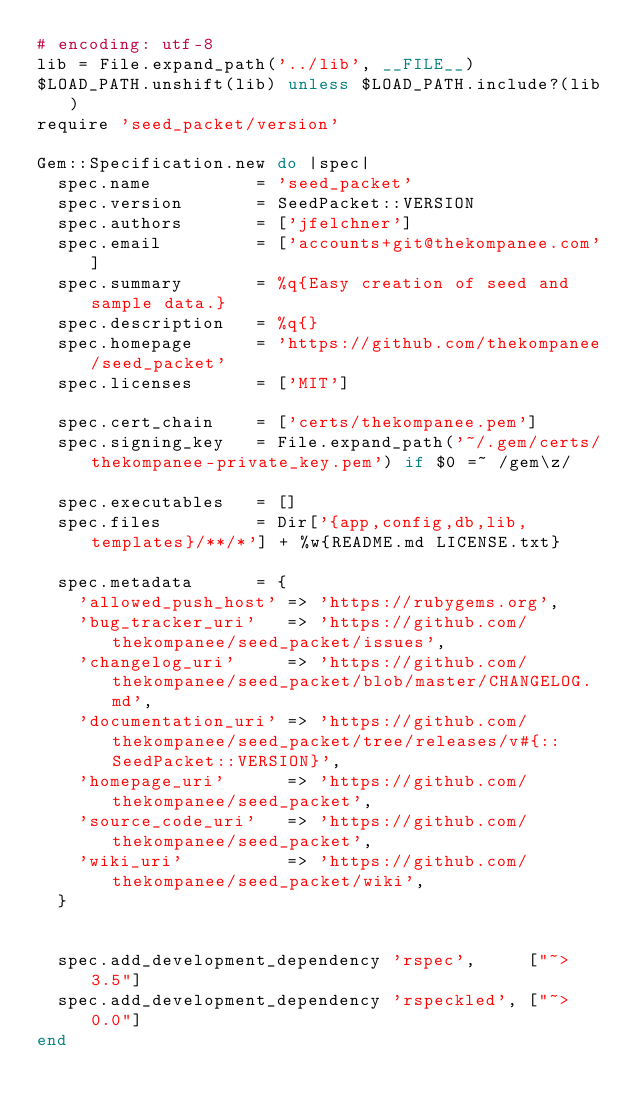Convert code to text. <code><loc_0><loc_0><loc_500><loc_500><_Ruby_># encoding: utf-8
lib = File.expand_path('../lib', __FILE__)
$LOAD_PATH.unshift(lib) unless $LOAD_PATH.include?(lib)
require 'seed_packet/version'

Gem::Specification.new do |spec|
  spec.name          = 'seed_packet'
  spec.version       = SeedPacket::VERSION
  spec.authors       = ['jfelchner']
  spec.email         = ['accounts+git@thekompanee.com']
  spec.summary       = %q{Easy creation of seed and sample data.}
  spec.description   = %q{}
  spec.homepage      = 'https://github.com/thekompanee/seed_packet'
  spec.licenses      = ['MIT']

  spec.cert_chain    = ['certs/thekompanee.pem']
  spec.signing_key   = File.expand_path('~/.gem/certs/thekompanee-private_key.pem') if $0 =~ /gem\z/

  spec.executables   = []
  spec.files         = Dir['{app,config,db,lib,templates}/**/*'] + %w{README.md LICENSE.txt}

  spec.metadata      = {
    'allowed_push_host' => 'https://rubygems.org',
    'bug_tracker_uri'   => 'https://github.com/thekompanee/seed_packet/issues',
    'changelog_uri'     => 'https://github.com/thekompanee/seed_packet/blob/master/CHANGELOG.md',
    'documentation_uri' => 'https://github.com/thekompanee/seed_packet/tree/releases/v#{::SeedPacket::VERSION}',
    'homepage_uri'      => 'https://github.com/thekompanee/seed_packet',
    'source_code_uri'   => 'https://github.com/thekompanee/seed_packet',
    'wiki_uri'          => 'https://github.com/thekompanee/seed_packet/wiki',
  }


  spec.add_development_dependency 'rspec',     ["~> 3.5"]
  spec.add_development_dependency 'rspeckled', ["~> 0.0"]
end
</code> 